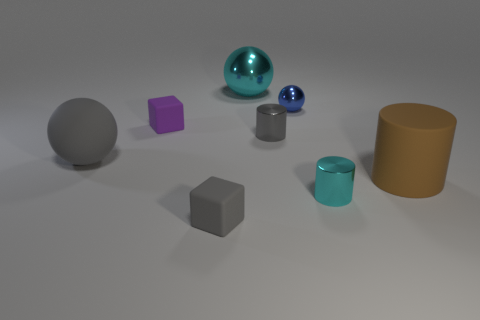Is there any other thing that has the same shape as the big cyan object?
Provide a short and direct response. Yes. What number of things are small green matte cylinders or rubber cylinders?
Offer a terse response. 1. Do the small blue metallic object and the tiny shiny object in front of the large gray sphere have the same shape?
Keep it short and to the point. No. There is a large rubber object on the right side of the small gray matte object; what shape is it?
Provide a succinct answer. Cylinder. Do the big gray thing and the small gray rubber thing have the same shape?
Make the answer very short. No. There is a cyan thing that is the same shape as the blue object; what is its size?
Provide a succinct answer. Large. Do the shiny cylinder that is in front of the gray cylinder and the cyan shiny sphere have the same size?
Provide a short and direct response. No. There is a metallic object that is left of the blue sphere and behind the purple rubber cube; what size is it?
Give a very brief answer. Large. There is a cylinder that is the same color as the large metal thing; what material is it?
Ensure brevity in your answer.  Metal. How many large rubber things have the same color as the matte cylinder?
Give a very brief answer. 0. 